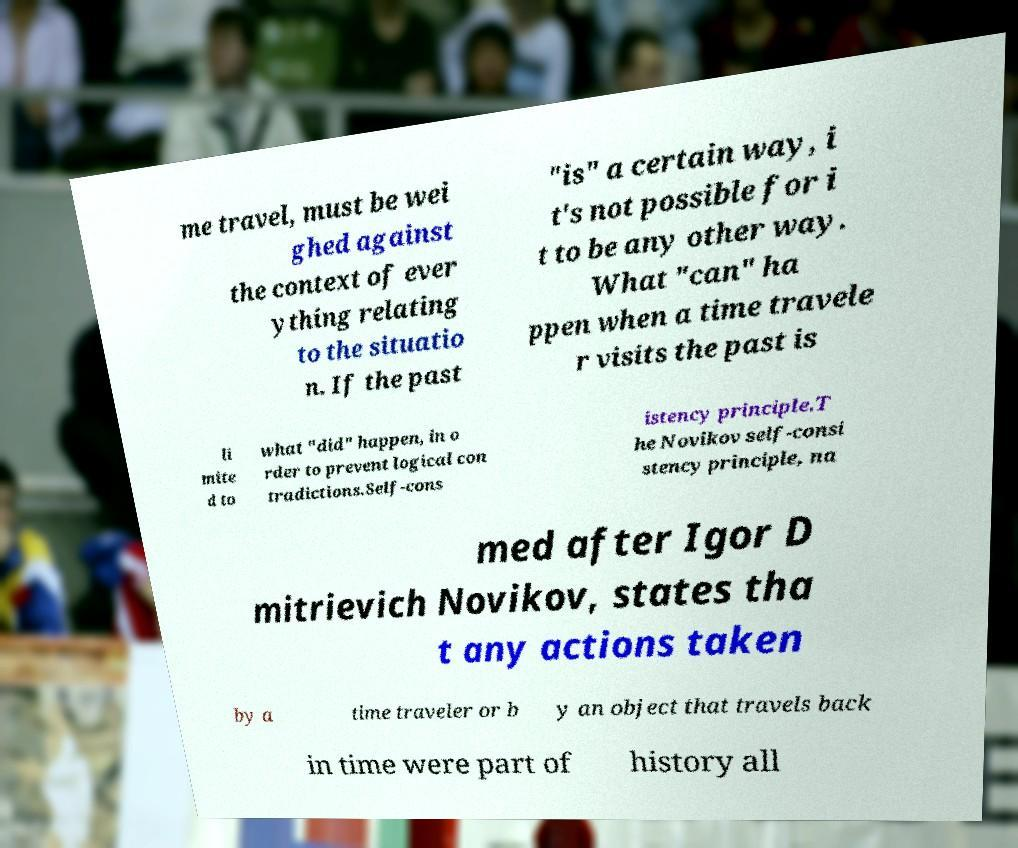Could you assist in decoding the text presented in this image and type it out clearly? me travel, must be wei ghed against the context of ever ything relating to the situatio n. If the past "is" a certain way, i t's not possible for i t to be any other way. What "can" ha ppen when a time travele r visits the past is li mite d to what "did" happen, in o rder to prevent logical con tradictions.Self-cons istency principle.T he Novikov self-consi stency principle, na med after Igor D mitrievich Novikov, states tha t any actions taken by a time traveler or b y an object that travels back in time were part of history all 